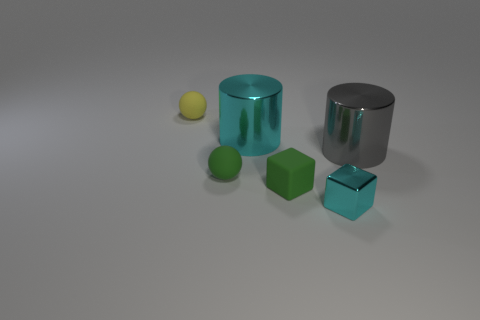There is a small object that is the same color as the matte cube; what shape is it?
Offer a terse response. Sphere. There is a sphere that is in front of the gray thing; does it have the same color as the tiny block that is left of the small cyan metallic cube?
Your response must be concise. Yes. There is a large metallic thing that is on the left side of the large gray metallic cylinder; is its color the same as the tiny metallic object?
Offer a terse response. Yes. The cube that is the same material as the tiny green sphere is what color?
Keep it short and to the point. Green. How many cylinders have the same size as the green sphere?
Ensure brevity in your answer.  0. How many other objects are the same color as the tiny metal cube?
Provide a succinct answer. 1. Is there any other thing that is the same size as the gray cylinder?
Provide a succinct answer. Yes. Does the tiny thing behind the big gray thing have the same shape as the big thing on the left side of the gray cylinder?
Provide a succinct answer. No. There is a green matte object that is the same size as the green cube; what is its shape?
Offer a terse response. Sphere. Are there an equal number of large gray metallic cylinders in front of the small green ball and tiny blocks right of the metal block?
Ensure brevity in your answer.  Yes. 